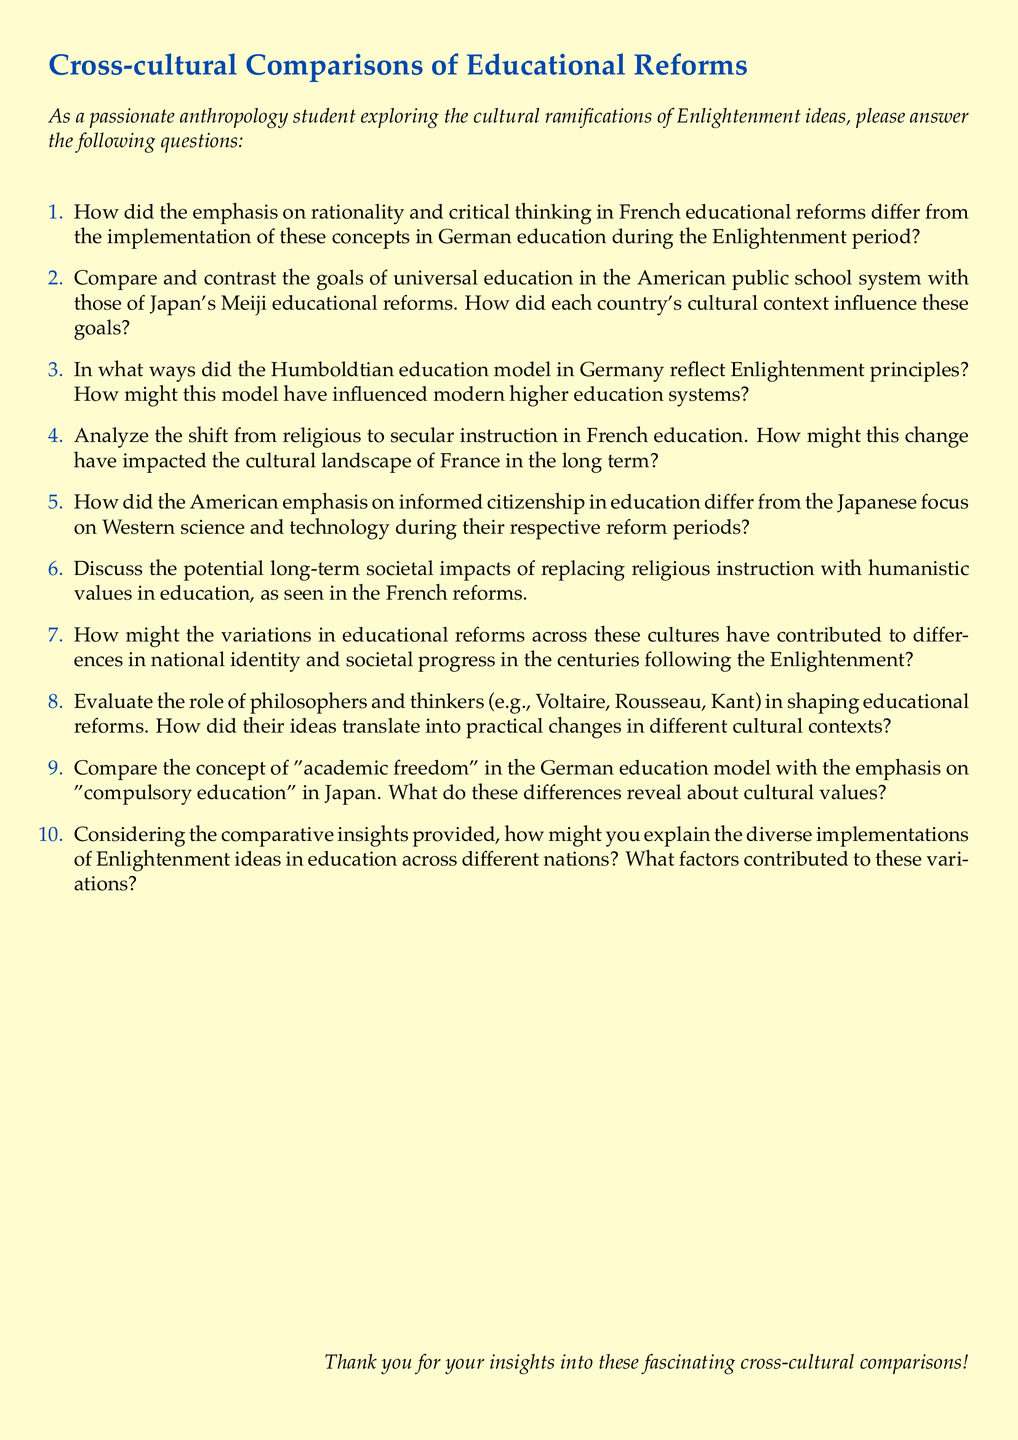What is the main focus of this questionnaire? The main focus of the questionnaire is to gather insights on cross-cultural comparisons of educational reforms inspired by Enlightenment ideas.
Answer: Cross-cultural comparisons of educational reforms How many questions are included in the document? The document includes a list of questions, specifically from 1 to 10.
Answer: 10 Which country's educational reforms emphasized rationality? The questionnaire specifically mentions France's educational reforms as emphasizing rationality.
Answer: France What is the title of the document? The title of the document is stated at the beginning and indicates its subject.
Answer: Cross-cultural Comparisons of Educational Reforms Who are some of the philosophers mentioned in the document? The document lists notable figures like Voltaire, Rousseau, and Kant who influenced educational reforms.
Answer: Voltaire, Rousseau, Kant What cultural aspect does question 6 focus on? Question 6 discusses the societal impacts of replacing religious instruction with humanistic values in education.
Answer: Societal impacts What model in Germany is referenced as reflecting Enlightenment principles? The Humboldtian education model is referenced in connection with Enlightenment principles.
Answer: Humboldtian education model What educational reform is mentioned in connection with Japan? The document refers to Japan's Meiji educational reforms as part of its educational context.
Answer: Meiji educational reforms What does question 9 compare regarding education models? Question 9 compares "academic freedom" in the German education model with "compulsory education" in Japan.
Answer: Academic freedom and compulsory education What element of culture is explored throughout the questions? The questions explore how educational reforms relate to national identity and societal progress in different cultures.
Answer: National identity and societal progress 